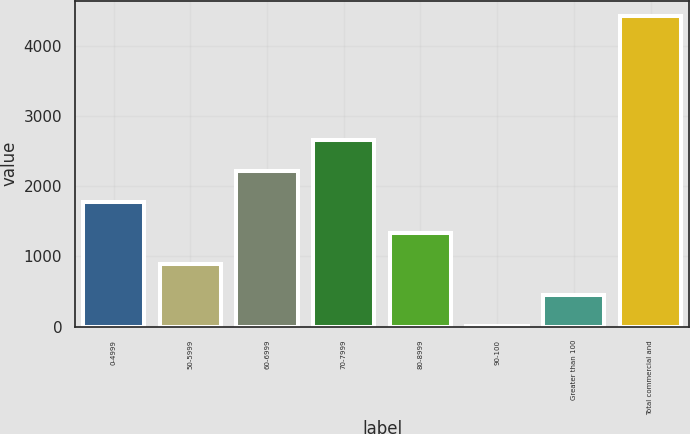Convert chart. <chart><loc_0><loc_0><loc_500><loc_500><bar_chart><fcel>0-4999<fcel>50-5999<fcel>60-6999<fcel>70-7999<fcel>80-8999<fcel>90-100<fcel>Greater than 100<fcel>Total commercial and<nl><fcel>1775<fcel>892<fcel>2216.5<fcel>2658<fcel>1333.5<fcel>9<fcel>450.5<fcel>4424<nl></chart> 